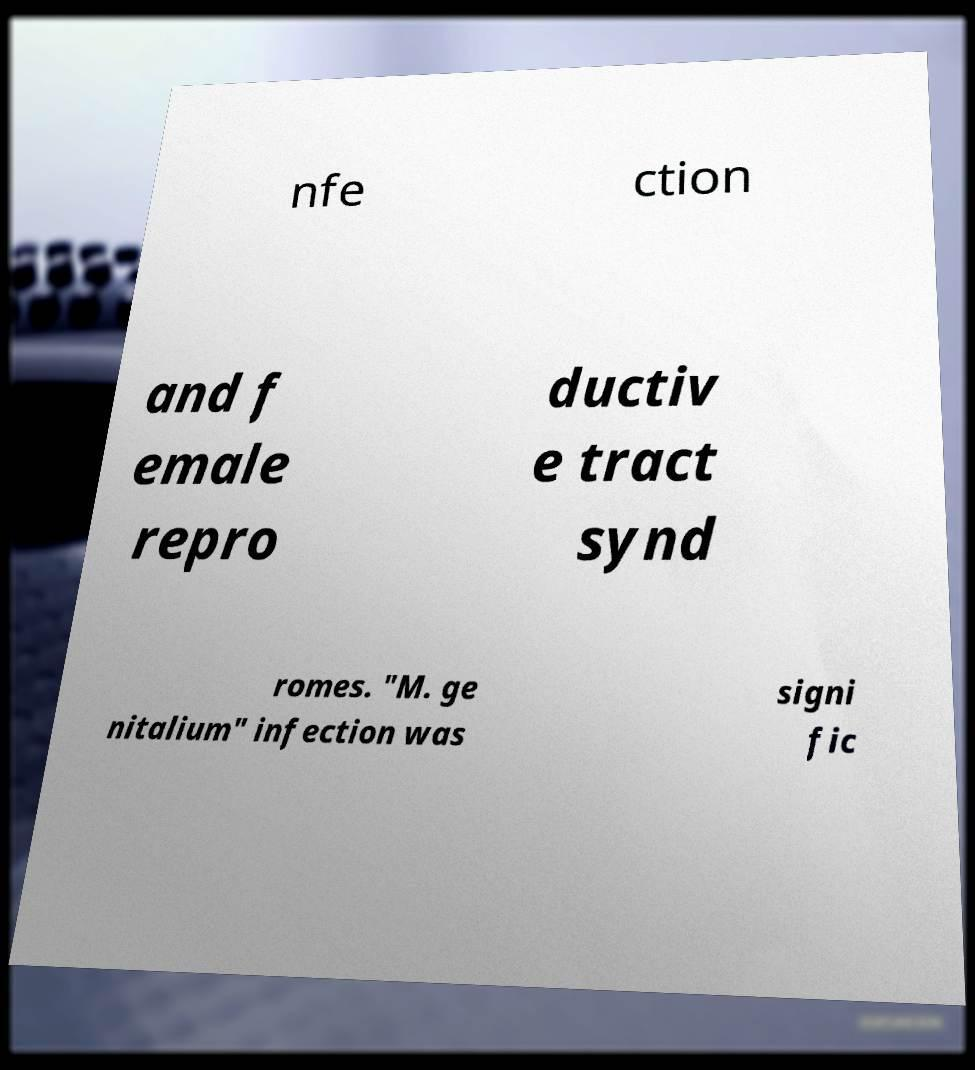Could you extract and type out the text from this image? nfe ction and f emale repro ductiv e tract synd romes. "M. ge nitalium" infection was signi fic 